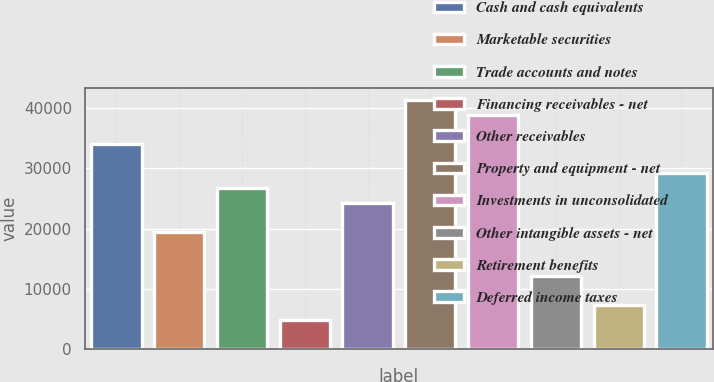<chart> <loc_0><loc_0><loc_500><loc_500><bar_chart><fcel>Cash and cash equivalents<fcel>Marketable securities<fcel>Trade accounts and notes<fcel>Financing receivables - net<fcel>Other receivables<fcel>Property and equipment - net<fcel>Investments in unconsolidated<fcel>Other intangible assets - net<fcel>Retirement benefits<fcel>Deferred income taxes<nl><fcel>33993.2<fcel>19428.2<fcel>26710.7<fcel>4863.28<fcel>24283.2<fcel>41275.6<fcel>38848.1<fcel>12145.8<fcel>7290.77<fcel>29138.2<nl></chart> 